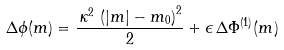<formula> <loc_0><loc_0><loc_500><loc_500>\Delta \phi ( m ) = \frac { \, \kappa ^ { 2 } \, \left ( | m | - m _ { 0 } \right ) ^ { 2 } } { 2 } + \epsilon \, \Delta \Phi ^ { ( 1 ) } ( m )</formula> 